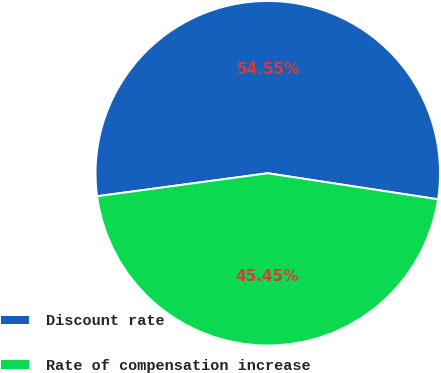Convert chart to OTSL. <chart><loc_0><loc_0><loc_500><loc_500><pie_chart><fcel>Discount rate<fcel>Rate of compensation increase<nl><fcel>54.55%<fcel>45.45%<nl></chart> 